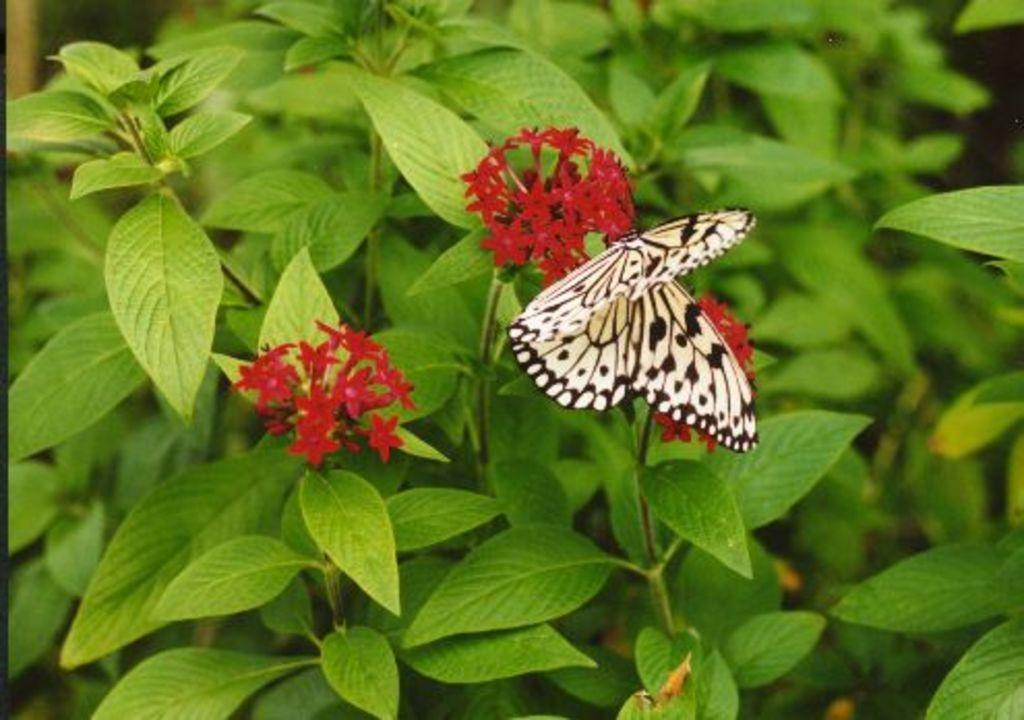What is the main subject of the image? The main subject of the image is a butterfly. Where is the butterfly located in the image? The butterfly is on plants. What can be observed about the plants in the image? The plants have red color flowers. What part of the butterfly is visible in the image? The entire butterfly is visible in the image, as it is not partially obscured or cut off. 